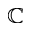Convert formula to latex. <formula><loc_0><loc_0><loc_500><loc_500>\mathbb { C }</formula> 